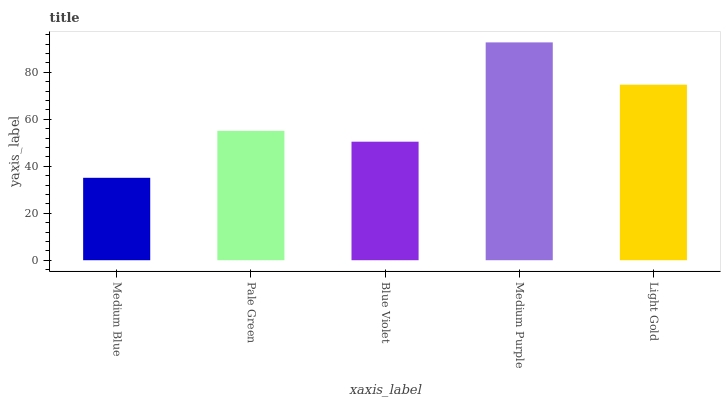Is Pale Green the minimum?
Answer yes or no. No. Is Pale Green the maximum?
Answer yes or no. No. Is Pale Green greater than Medium Blue?
Answer yes or no. Yes. Is Medium Blue less than Pale Green?
Answer yes or no. Yes. Is Medium Blue greater than Pale Green?
Answer yes or no. No. Is Pale Green less than Medium Blue?
Answer yes or no. No. Is Pale Green the high median?
Answer yes or no. Yes. Is Pale Green the low median?
Answer yes or no. Yes. Is Medium Purple the high median?
Answer yes or no. No. Is Blue Violet the low median?
Answer yes or no. No. 